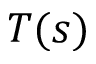Convert formula to latex. <formula><loc_0><loc_0><loc_500><loc_500>T ( s )</formula> 